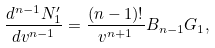Convert formula to latex. <formula><loc_0><loc_0><loc_500><loc_500>\frac { d ^ { n - 1 } N _ { 1 } ^ { \prime } } { d v ^ { n - 1 } } = \frac { ( n - 1 ) ! } { v ^ { n + 1 } } B _ { n - 1 } G _ { 1 } ,</formula> 